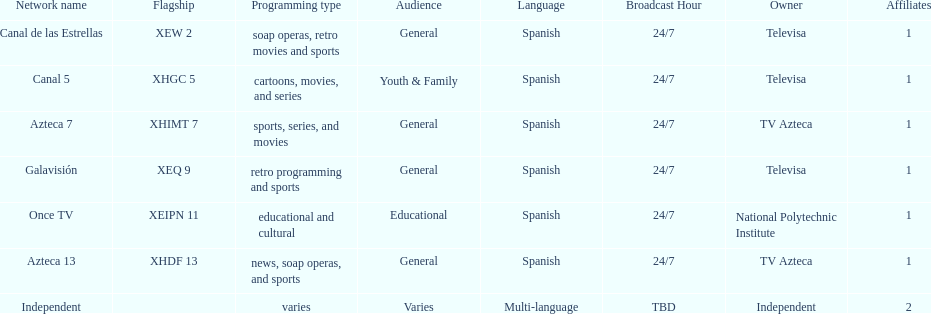Name a station that shows sports but is not televisa. Azteca 7. 